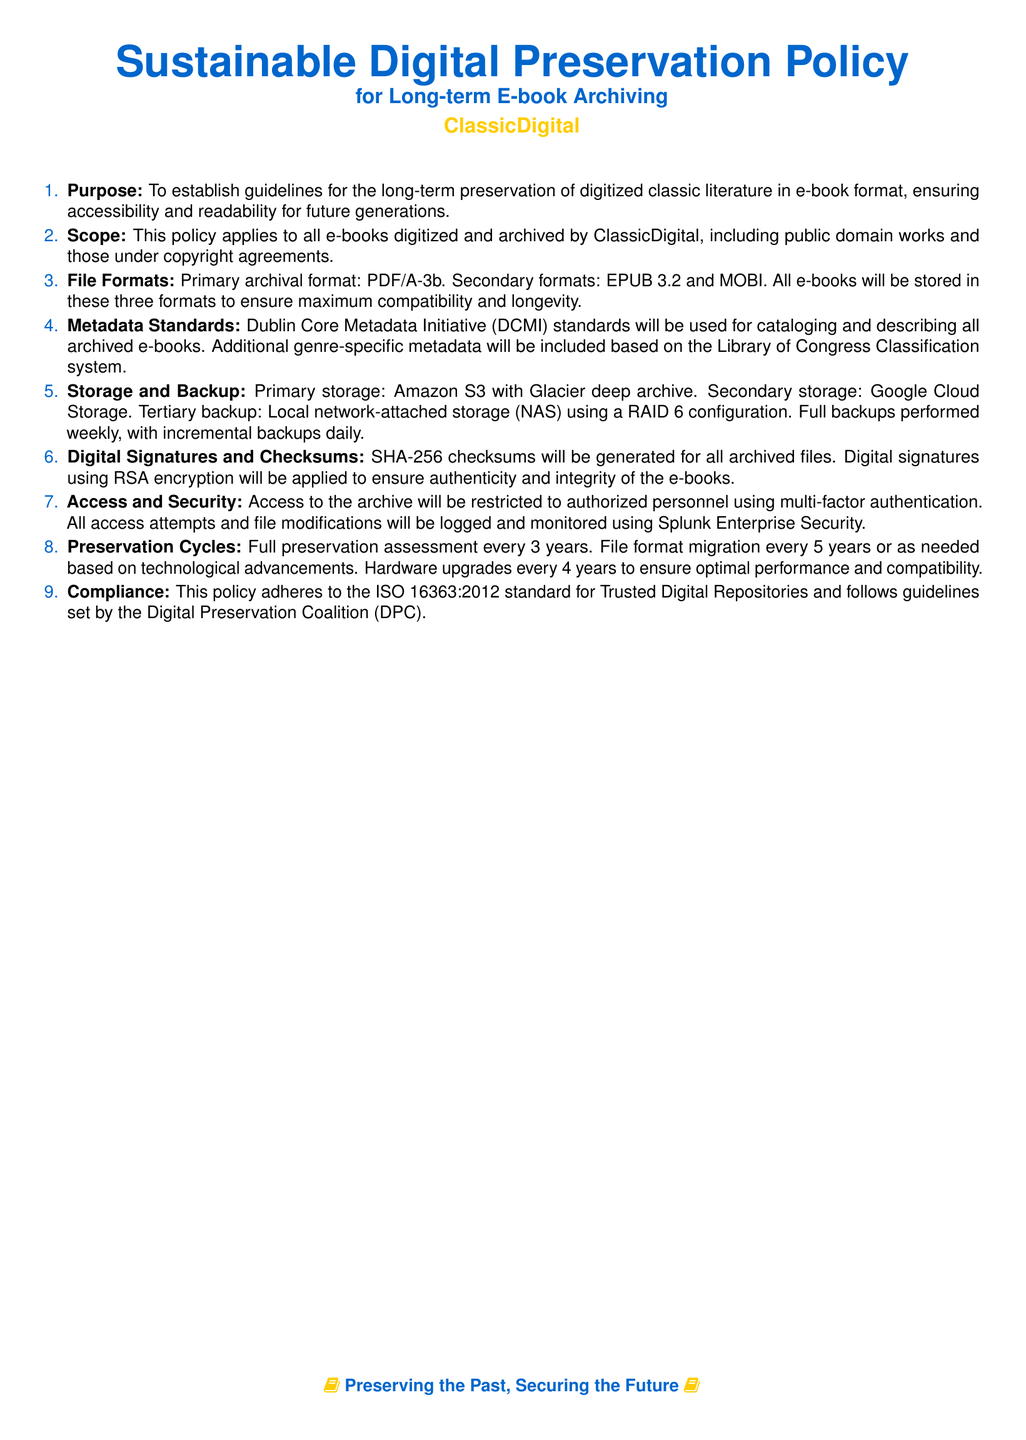What is the primary archival format? The primary archival format is specified in the document under the file formats section, which mentions PDF/A-3b.
Answer: PDF/A-3b How often will full preservation assessments occur? This information is found in the preservation cycles section, which states that full preservation assessments will occur every 3 years.
Answer: 3 years Which metadata standards are used for cataloging? The document specifies that the Dublin Core Metadata Initiative (DCMI) standards will be used for cataloging e-books.
Answer: Dublin Core Metadata Initiative What type of encryption is used for digital signatures? The document details under digital signatures and checksums that RSA encryption is used for digital signatures.
Answer: RSA What is the secondary storage solution mentioned? The secondary storage solution is outlined in the storage and backup section, indicating Google Cloud Storage as the secondary option.
Answer: Google Cloud Storage How many formats are specified for e-book storage? The file formats section outlines that there are three specified formats for e-book storage.
Answer: Three What is the purpose of this policy document? The purpose of the document is clearly delineated in the purpose section stating guidelines for long-term preservation of digitized classic literature.
Answer: Long-term preservation How often will file format migration occur? The preservation cycles section indicates that file format migration will occur every 5 years or as needed.
Answer: 5 years 